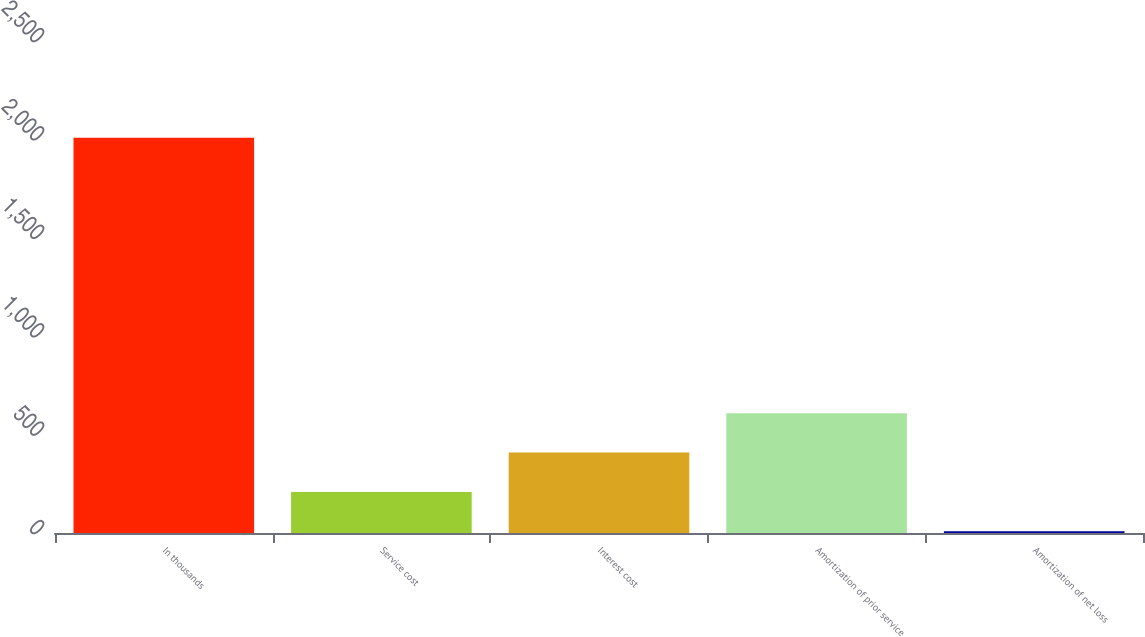Convert chart. <chart><loc_0><loc_0><loc_500><loc_500><bar_chart><fcel>In thousands<fcel>Service cost<fcel>Interest cost<fcel>Amortization of prior service<fcel>Amortization of net loss<nl><fcel>2008<fcel>208.9<fcel>408.8<fcel>608.7<fcel>9<nl></chart> 